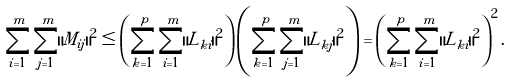<formula> <loc_0><loc_0><loc_500><loc_500>\sum _ { i = 1 } ^ { m } \sum _ { j = 1 } ^ { m } \| M _ { i j } \| ^ { 2 } \leq \left ( \sum _ { k = 1 } ^ { p } \sum _ { i = 1 } ^ { m } \| L _ { k i } \| ^ { 2 } \right ) \left ( \sum _ { k = 1 } ^ { p } \sum _ { j = 1 } ^ { m } \| L _ { k j } \| ^ { 2 } \right ) = \left ( \sum _ { k = 1 } ^ { p } \sum _ { i = 1 } ^ { m } \| L _ { k i } \| ^ { 2 } \right ) ^ { 2 } .</formula> 